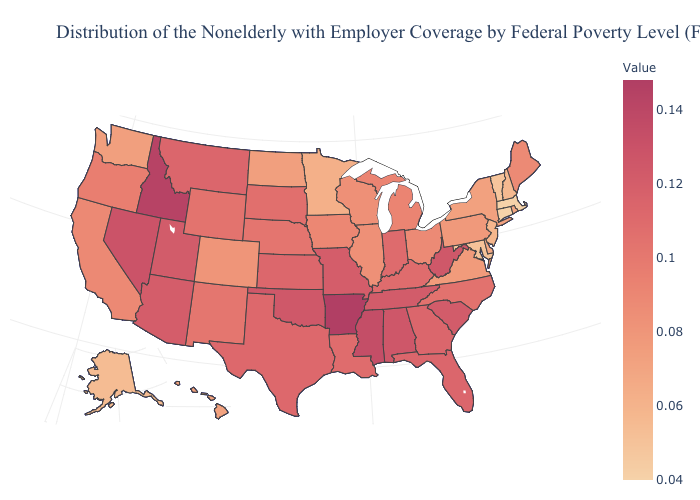Does the map have missing data?
Short answer required. No. Which states hav the highest value in the MidWest?
Give a very brief answer. Missouri. Does Oklahoma have a higher value than Idaho?
Concise answer only. No. Which states hav the highest value in the MidWest?
Give a very brief answer. Missouri. Which states hav the highest value in the West?
Short answer required. Idaho. 